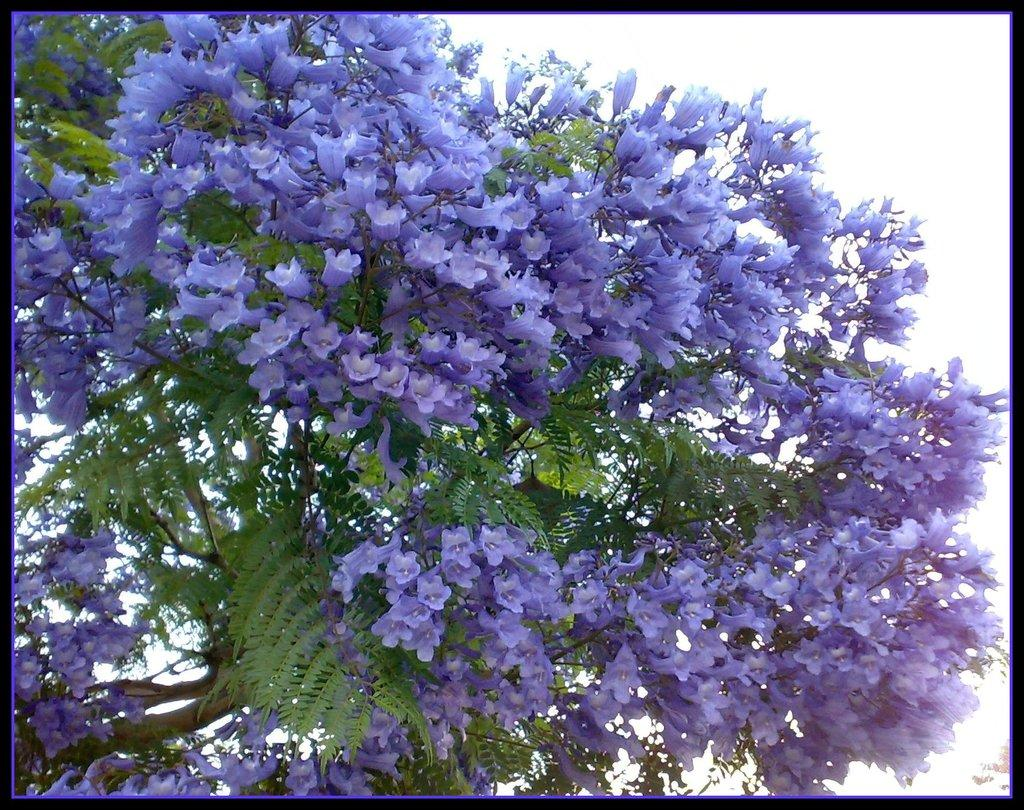What type of plant can be seen in the image? There is a tree in the image. What is the condition of the tree's leaves? The tree has leaves. What color are the flowers on the tree? The tree has violet-colored flowers. Where is the lunchroom located in the image? There is: There is no lunchroom present in the image; it features a tree with leaves and violet-colored flowers. 